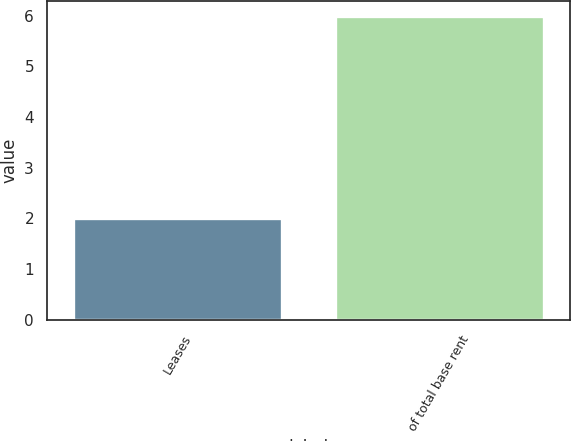Convert chart to OTSL. <chart><loc_0><loc_0><loc_500><loc_500><bar_chart><fcel>Leases<fcel>of total base rent<nl><fcel>2<fcel>6<nl></chart> 